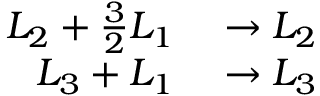Convert formula to latex. <formula><loc_0><loc_0><loc_500><loc_500>\begin{array} { r l } { L _ { 2 } + { \frac { 3 } { 2 } } L _ { 1 } } & \to L _ { 2 } } \\ { L _ { 3 } + L _ { 1 } } & \to L _ { 3 } } \end{array}</formula> 